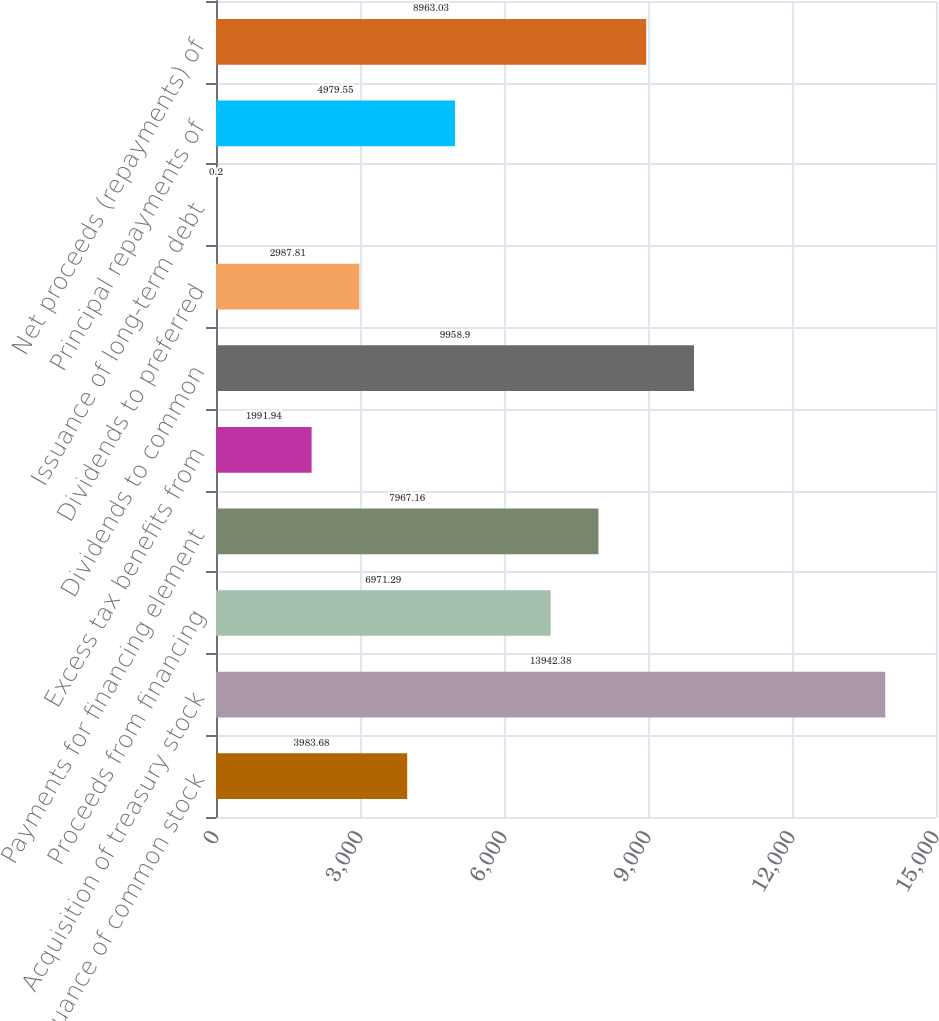Convert chart. <chart><loc_0><loc_0><loc_500><loc_500><bar_chart><fcel>Issuance of common stock<fcel>Acquisition of treasury stock<fcel>Proceeds from financing<fcel>Payments for financing element<fcel>Excess tax benefits from<fcel>Dividends to common<fcel>Dividends to preferred<fcel>Issuance of long-term debt<fcel>Principal repayments of<fcel>Net proceeds (repayments) of<nl><fcel>3983.68<fcel>13942.4<fcel>6971.29<fcel>7967.16<fcel>1991.94<fcel>9958.9<fcel>2987.81<fcel>0.2<fcel>4979.55<fcel>8963.03<nl></chart> 